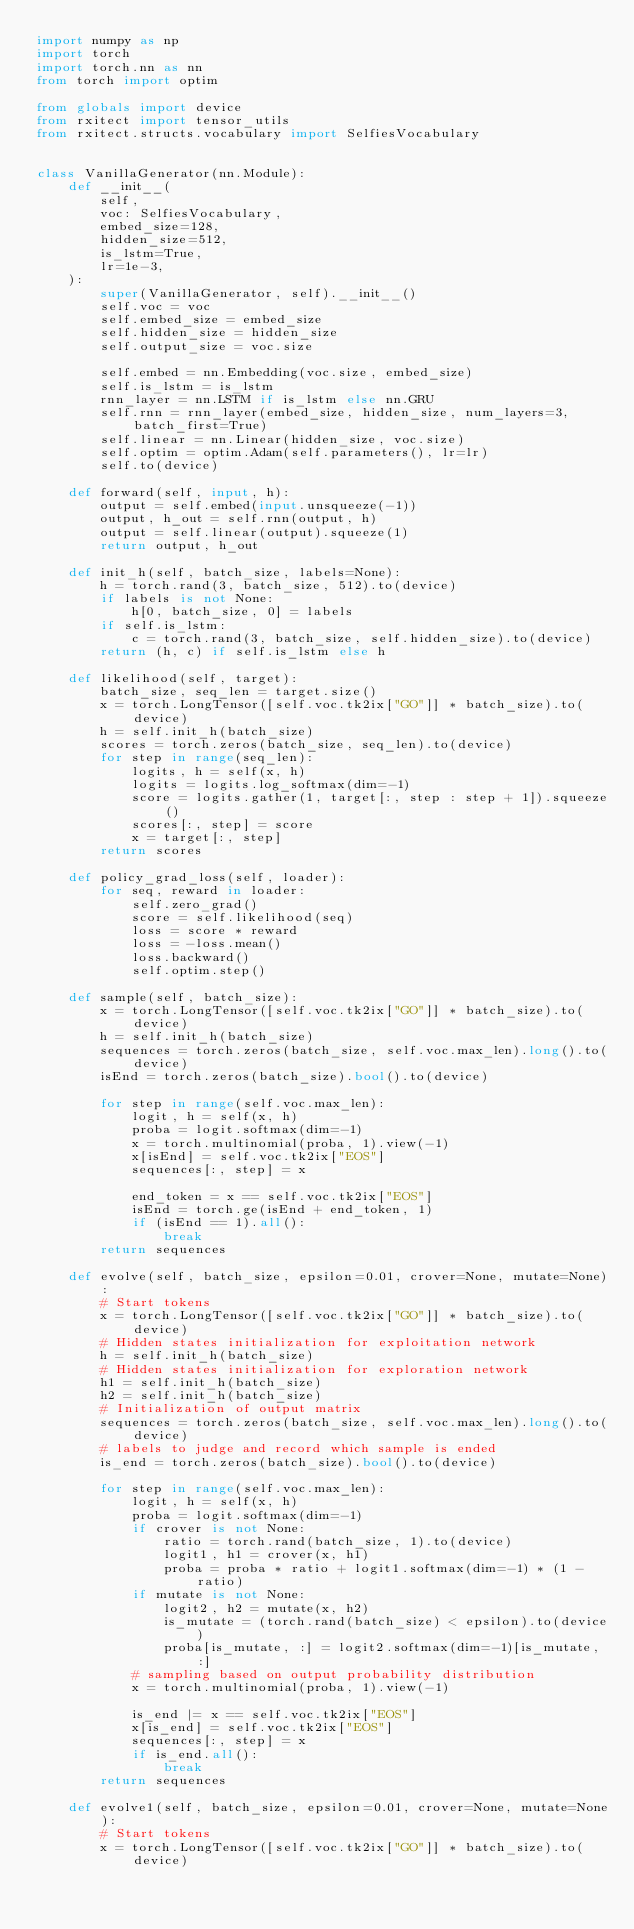Convert code to text. <code><loc_0><loc_0><loc_500><loc_500><_Python_>import numpy as np
import torch
import torch.nn as nn
from torch import optim

from globals import device
from rxitect import tensor_utils
from rxitect.structs.vocabulary import SelfiesVocabulary


class VanillaGenerator(nn.Module):
    def __init__(
        self,
        voc: SelfiesVocabulary,
        embed_size=128,
        hidden_size=512,
        is_lstm=True,
        lr=1e-3,
    ):
        super(VanillaGenerator, self).__init__()
        self.voc = voc
        self.embed_size = embed_size
        self.hidden_size = hidden_size
        self.output_size = voc.size

        self.embed = nn.Embedding(voc.size, embed_size)
        self.is_lstm = is_lstm
        rnn_layer = nn.LSTM if is_lstm else nn.GRU
        self.rnn = rnn_layer(embed_size, hidden_size, num_layers=3, batch_first=True)
        self.linear = nn.Linear(hidden_size, voc.size)
        self.optim = optim.Adam(self.parameters(), lr=lr)
        self.to(device)

    def forward(self, input, h):
        output = self.embed(input.unsqueeze(-1))
        output, h_out = self.rnn(output, h)
        output = self.linear(output).squeeze(1)
        return output, h_out

    def init_h(self, batch_size, labels=None):
        h = torch.rand(3, batch_size, 512).to(device)
        if labels is not None:
            h[0, batch_size, 0] = labels
        if self.is_lstm:
            c = torch.rand(3, batch_size, self.hidden_size).to(device)
        return (h, c) if self.is_lstm else h

    def likelihood(self, target):
        batch_size, seq_len = target.size()
        x = torch.LongTensor([self.voc.tk2ix["GO"]] * batch_size).to(device)
        h = self.init_h(batch_size)
        scores = torch.zeros(batch_size, seq_len).to(device)
        for step in range(seq_len):
            logits, h = self(x, h)
            logits = logits.log_softmax(dim=-1)
            score = logits.gather(1, target[:, step : step + 1]).squeeze()
            scores[:, step] = score
            x = target[:, step]
        return scores

    def policy_grad_loss(self, loader):
        for seq, reward in loader:
            self.zero_grad()
            score = self.likelihood(seq)
            loss = score * reward
            loss = -loss.mean()
            loss.backward()
            self.optim.step()

    def sample(self, batch_size):
        x = torch.LongTensor([self.voc.tk2ix["GO"]] * batch_size).to(device)
        h = self.init_h(batch_size)
        sequences = torch.zeros(batch_size, self.voc.max_len).long().to(device)
        isEnd = torch.zeros(batch_size).bool().to(device)

        for step in range(self.voc.max_len):
            logit, h = self(x, h)
            proba = logit.softmax(dim=-1)
            x = torch.multinomial(proba, 1).view(-1)
            x[isEnd] = self.voc.tk2ix["EOS"]
            sequences[:, step] = x

            end_token = x == self.voc.tk2ix["EOS"]
            isEnd = torch.ge(isEnd + end_token, 1)
            if (isEnd == 1).all():
                break
        return sequences

    def evolve(self, batch_size, epsilon=0.01, crover=None, mutate=None):
        # Start tokens
        x = torch.LongTensor([self.voc.tk2ix["GO"]] * batch_size).to(device)
        # Hidden states initialization for exploitation network
        h = self.init_h(batch_size)
        # Hidden states initialization for exploration network
        h1 = self.init_h(batch_size)
        h2 = self.init_h(batch_size)
        # Initialization of output matrix
        sequences = torch.zeros(batch_size, self.voc.max_len).long().to(device)
        # labels to judge and record which sample is ended
        is_end = torch.zeros(batch_size).bool().to(device)

        for step in range(self.voc.max_len):
            logit, h = self(x, h)
            proba = logit.softmax(dim=-1)
            if crover is not None:
                ratio = torch.rand(batch_size, 1).to(device)
                logit1, h1 = crover(x, h1)
                proba = proba * ratio + logit1.softmax(dim=-1) * (1 - ratio)
            if mutate is not None:
                logit2, h2 = mutate(x, h2)
                is_mutate = (torch.rand(batch_size) < epsilon).to(device)
                proba[is_mutate, :] = logit2.softmax(dim=-1)[is_mutate, :]
            # sampling based on output probability distribution
            x = torch.multinomial(proba, 1).view(-1)

            is_end |= x == self.voc.tk2ix["EOS"]
            x[is_end] = self.voc.tk2ix["EOS"]
            sequences[:, step] = x
            if is_end.all():
                break
        return sequences

    def evolve1(self, batch_size, epsilon=0.01, crover=None, mutate=None):
        # Start tokens
        x = torch.LongTensor([self.voc.tk2ix["GO"]] * batch_size).to(device)</code> 